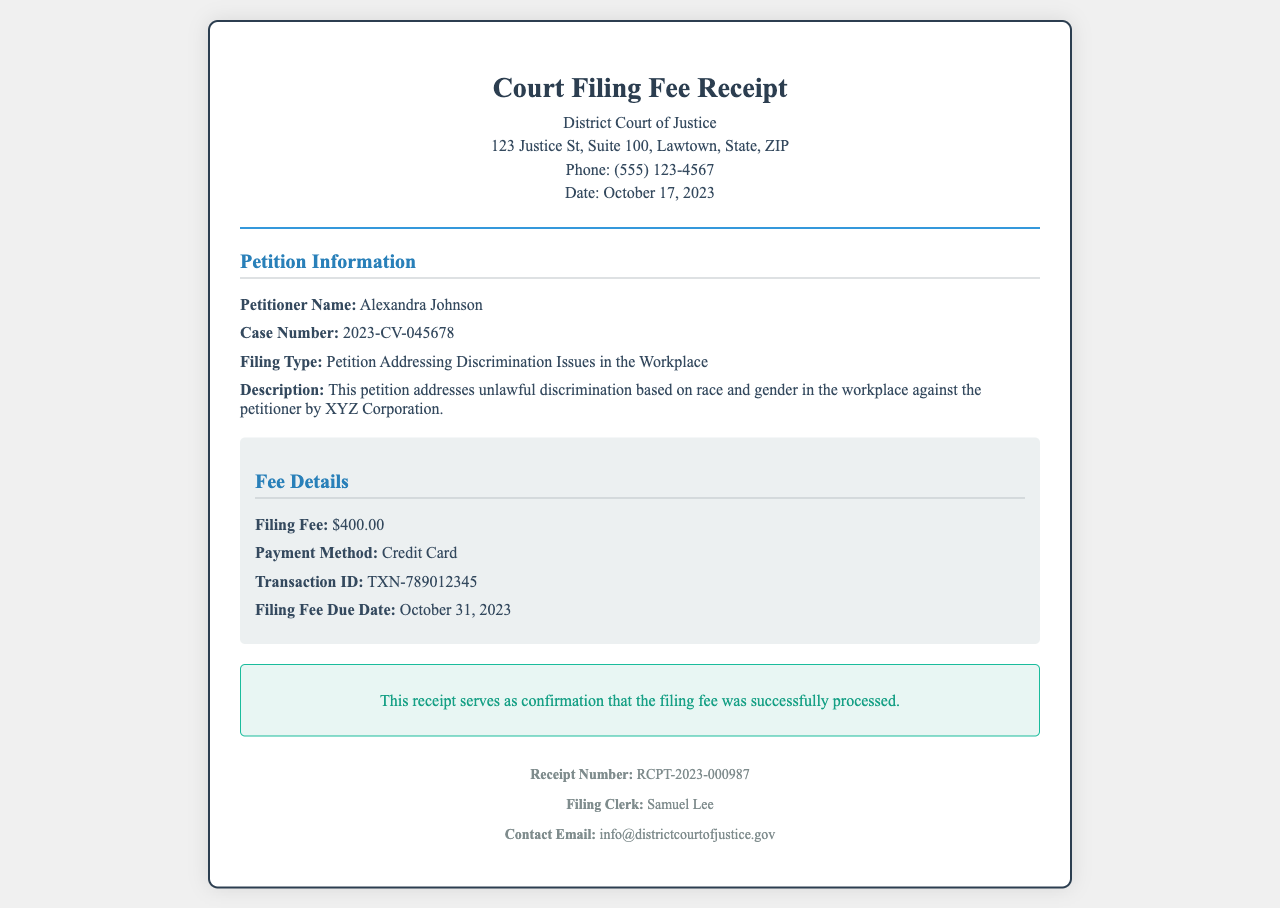What is the name of the petitioner? The petitioner's name is clearly specified in the document under the Petition Information section.
Answer: Alexandra Johnson What is the case number? The case number is provided next to the petitioner's information in the document.
Answer: 2023-CV-045678 What is the filing fee amount? The document lists the fee amount in the Fee Details section.
Answer: $400.00 What is the payment method used for the filing fee? The payment method is mentioned under the Fee Details section of the document.
Answer: Credit Card What is the due date for the filing fee? The due date for the filing fee is specified in the Fee Details section.
Answer: October 31, 2023 Who is the filing clerk? The name of the filing clerk is provided in the footer of the document.
Answer: Samuel Lee What type of petition is filed? The filing type is described in the Petition Information section.
Answer: Petition Addressing Discrimination Issues in the Workplace What email can be used for contact inquiries? The document provides a contact email address in the footer section.
Answer: info@districtcourtofjustice.gov What is the transaction ID for the payment? The transaction ID is specified in the Fee Details section for reference.
Answer: TXN-789012345 